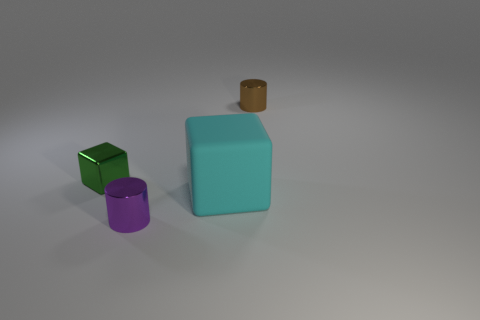What is the color of the other small shiny thing that is the same shape as the small brown metal thing?
Your answer should be compact. Purple. There is a object that is right of the purple thing and in front of the brown metal cylinder; what is its shape?
Offer a very short reply. Cube. Is the number of brown shiny cylinders less than the number of yellow shiny objects?
Provide a succinct answer. No. Are any purple metallic spheres visible?
Offer a very short reply. No. What number of other things are the same size as the green shiny thing?
Offer a very short reply. 2. Is the material of the tiny green object the same as the big object that is on the left side of the small brown thing?
Provide a short and direct response. No. Are there an equal number of cylinders on the left side of the green object and cylinders that are in front of the brown object?
Offer a very short reply. No. What is the green block made of?
Your answer should be very brief. Metal. What color is the cylinder that is the same size as the purple metal object?
Give a very brief answer. Brown. There is a tiny cylinder that is in front of the tiny green block; are there any cylinders that are behind it?
Keep it short and to the point. Yes. 